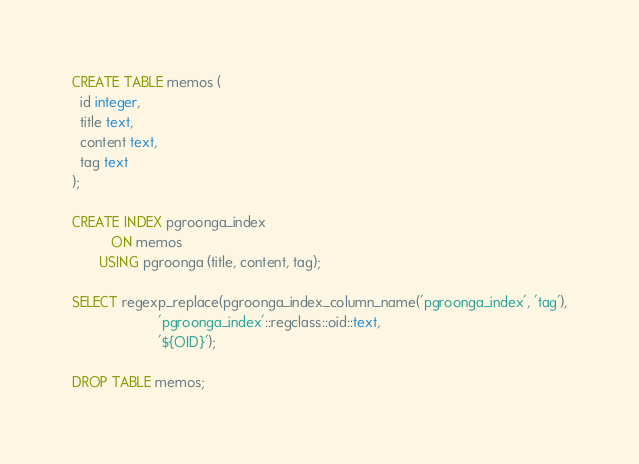Convert code to text. <code><loc_0><loc_0><loc_500><loc_500><_SQL_>CREATE TABLE memos (
  id integer,
  title text,
  content text,
  tag text
);

CREATE INDEX pgroonga_index
          ON memos
       USING pgroonga (title, content, tag);

SELECT regexp_replace(pgroonga_index_column_name('pgroonga_index', 'tag'),
                      'pgroonga_index'::regclass::oid::text,
                      '${OID}');

DROP TABLE memos;

</code> 